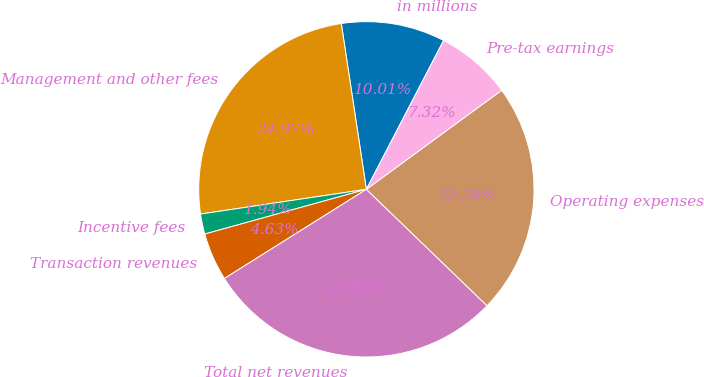Convert chart to OTSL. <chart><loc_0><loc_0><loc_500><loc_500><pie_chart><fcel>in millions<fcel>Management and other fees<fcel>Incentive fees<fcel>Transaction revenues<fcel>Total net revenues<fcel>Operating expenses<fcel>Pre-tax earnings<nl><fcel>10.01%<fcel>24.97%<fcel>1.94%<fcel>4.63%<fcel>28.86%<fcel>22.28%<fcel>7.32%<nl></chart> 